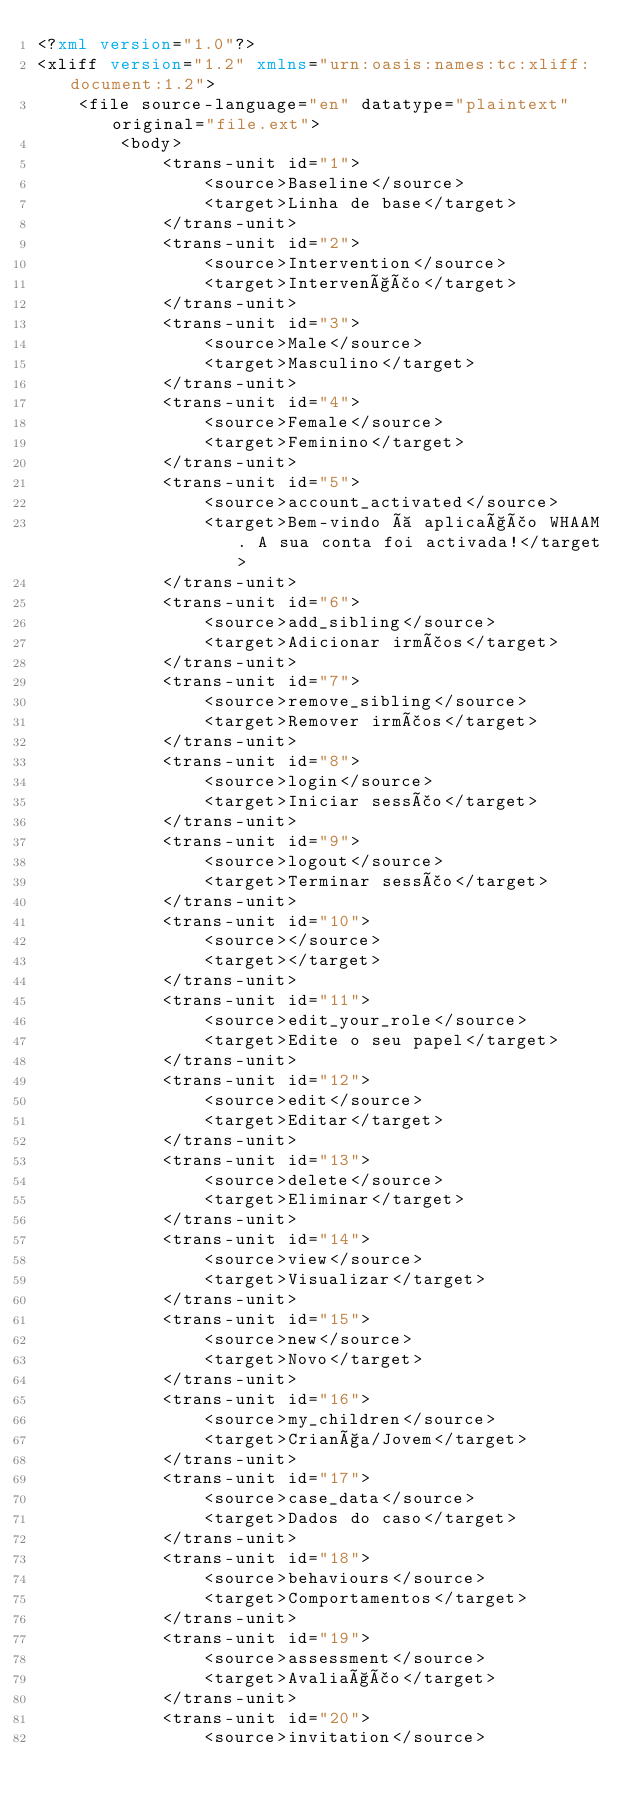Convert code to text. <code><loc_0><loc_0><loc_500><loc_500><_XML_><?xml version="1.0"?>
<xliff version="1.2" xmlns="urn:oasis:names:tc:xliff:document:1.2">
    <file source-language="en" datatype="plaintext" original="file.ext">
        <body>
            <trans-unit id="1">
                <source>Baseline</source>
                <target>Linha de base</target>
            </trans-unit>
            <trans-unit id="2">
                <source>Intervention</source>
                <target>Intervenção</target>
            </trans-unit>
            <trans-unit id="3">
                <source>Male</source>
                <target>Masculino</target>
            </trans-unit>
            <trans-unit id="4">
                <source>Female</source>
                <target>Feminino</target>
            </trans-unit>
            <trans-unit id="5">
                <source>account_activated</source>
                <target>Bem-vindo à aplicação WHAAM. A sua conta foi activada!</target>
            </trans-unit>
            <trans-unit id="6">
                <source>add_sibling</source>
                <target>Adicionar irmãos</target>
            </trans-unit>
            <trans-unit id="7">
                <source>remove_sibling</source>
                <target>Remover irmãos</target>
            </trans-unit>
            <trans-unit id="8">
                <source>login</source>
                <target>Iniciar sessão</target>
            </trans-unit>
            <trans-unit id="9">
                <source>logout</source>
                <target>Terminar sessão</target>
            </trans-unit>
            <trans-unit id="10">
                <source></source>
                <target></target>
            </trans-unit>
            <trans-unit id="11">
                <source>edit_your_role</source>
                <target>Edite o seu papel</target>
            </trans-unit>
            <trans-unit id="12">
                <source>edit</source>
                <target>Editar</target>
            </trans-unit>
            <trans-unit id="13">
                <source>delete</source>
                <target>Eliminar</target>
            </trans-unit>
            <trans-unit id="14">
                <source>view</source>
                <target>Visualizar</target>
            </trans-unit>
            <trans-unit id="15">
                <source>new</source>
                <target>Novo</target>
            </trans-unit>
            <trans-unit id="16">
                <source>my_children</source>
                <target>Criança/Jovem</target>
            </trans-unit>
            <trans-unit id="17">
                <source>case_data</source>
                <target>Dados do caso</target>
            </trans-unit>
            <trans-unit id="18">
                <source>behaviours</source>
                <target>Comportamentos</target>
            </trans-unit>
            <trans-unit id="19">
                <source>assessment</source>
                <target>Avaliação</target>
            </trans-unit>
            <trans-unit id="20">
                <source>invitation</source></code> 